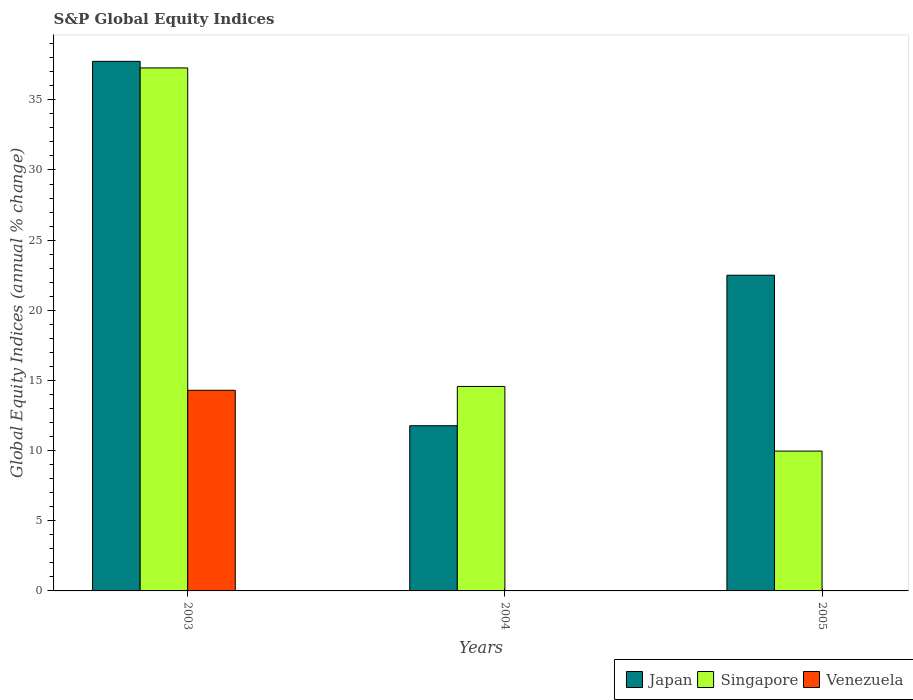How many different coloured bars are there?
Make the answer very short. 3. Are the number of bars per tick equal to the number of legend labels?
Your response must be concise. No. How many bars are there on the 1st tick from the left?
Your answer should be very brief. 3. In how many cases, is the number of bars for a given year not equal to the number of legend labels?
Ensure brevity in your answer.  2. What is the global equity indices in Japan in 2004?
Keep it short and to the point. 11.77. Across all years, what is the maximum global equity indices in Singapore?
Your answer should be very brief. 37.27. Across all years, what is the minimum global equity indices in Japan?
Your response must be concise. 11.77. In which year was the global equity indices in Singapore maximum?
Offer a terse response. 2003. What is the total global equity indices in Singapore in the graph?
Make the answer very short. 61.81. What is the difference between the global equity indices in Japan in 2003 and that in 2005?
Make the answer very short. 15.24. What is the difference between the global equity indices in Japan in 2005 and the global equity indices in Singapore in 2003?
Your response must be concise. -14.77. What is the average global equity indices in Singapore per year?
Your answer should be very brief. 20.6. In the year 2004, what is the difference between the global equity indices in Singapore and global equity indices in Japan?
Your answer should be compact. 2.8. In how many years, is the global equity indices in Japan greater than 6 %?
Keep it short and to the point. 3. What is the ratio of the global equity indices in Singapore in 2004 to that in 2005?
Your response must be concise. 1.46. Is the global equity indices in Singapore in 2003 less than that in 2004?
Your answer should be compact. No. Is the difference between the global equity indices in Singapore in 2003 and 2004 greater than the difference between the global equity indices in Japan in 2003 and 2004?
Make the answer very short. No. What is the difference between the highest and the second highest global equity indices in Japan?
Provide a short and direct response. 15.24. What is the difference between the highest and the lowest global equity indices in Japan?
Give a very brief answer. 25.97. In how many years, is the global equity indices in Venezuela greater than the average global equity indices in Venezuela taken over all years?
Provide a short and direct response. 1. Is it the case that in every year, the sum of the global equity indices in Singapore and global equity indices in Japan is greater than the global equity indices in Venezuela?
Your answer should be compact. Yes. Are the values on the major ticks of Y-axis written in scientific E-notation?
Offer a terse response. No. Does the graph contain any zero values?
Offer a terse response. Yes. Does the graph contain grids?
Offer a very short reply. No. How are the legend labels stacked?
Give a very brief answer. Horizontal. What is the title of the graph?
Offer a terse response. S&P Global Equity Indices. Does "Liechtenstein" appear as one of the legend labels in the graph?
Your response must be concise. No. What is the label or title of the Y-axis?
Give a very brief answer. Global Equity Indices (annual % change). What is the Global Equity Indices (annual % change) of Japan in 2003?
Provide a short and direct response. 37.74. What is the Global Equity Indices (annual % change) in Singapore in 2003?
Give a very brief answer. 37.27. What is the Global Equity Indices (annual % change) of Venezuela in 2003?
Your answer should be compact. 14.3. What is the Global Equity Indices (annual % change) in Japan in 2004?
Keep it short and to the point. 11.77. What is the Global Equity Indices (annual % change) of Singapore in 2004?
Your answer should be very brief. 14.57. What is the Global Equity Indices (annual % change) of Venezuela in 2004?
Offer a terse response. 0. What is the Global Equity Indices (annual % change) in Japan in 2005?
Offer a terse response. 22.5. What is the Global Equity Indices (annual % change) in Singapore in 2005?
Offer a terse response. 9.97. Across all years, what is the maximum Global Equity Indices (annual % change) of Japan?
Keep it short and to the point. 37.74. Across all years, what is the maximum Global Equity Indices (annual % change) of Singapore?
Your answer should be compact. 37.27. Across all years, what is the maximum Global Equity Indices (annual % change) of Venezuela?
Give a very brief answer. 14.3. Across all years, what is the minimum Global Equity Indices (annual % change) of Japan?
Provide a short and direct response. 11.77. Across all years, what is the minimum Global Equity Indices (annual % change) in Singapore?
Offer a terse response. 9.97. What is the total Global Equity Indices (annual % change) in Japan in the graph?
Your answer should be very brief. 72.01. What is the total Global Equity Indices (annual % change) of Singapore in the graph?
Ensure brevity in your answer.  61.81. What is the total Global Equity Indices (annual % change) in Venezuela in the graph?
Provide a succinct answer. 14.3. What is the difference between the Global Equity Indices (annual % change) in Japan in 2003 and that in 2004?
Your answer should be compact. 25.97. What is the difference between the Global Equity Indices (annual % change) of Singapore in 2003 and that in 2004?
Your response must be concise. 22.7. What is the difference between the Global Equity Indices (annual % change) of Japan in 2003 and that in 2005?
Your answer should be compact. 15.24. What is the difference between the Global Equity Indices (annual % change) in Singapore in 2003 and that in 2005?
Offer a terse response. 27.31. What is the difference between the Global Equity Indices (annual % change) in Japan in 2004 and that in 2005?
Provide a succinct answer. -10.73. What is the difference between the Global Equity Indices (annual % change) in Singapore in 2004 and that in 2005?
Give a very brief answer. 4.61. What is the difference between the Global Equity Indices (annual % change) of Japan in 2003 and the Global Equity Indices (annual % change) of Singapore in 2004?
Offer a very short reply. 23.17. What is the difference between the Global Equity Indices (annual % change) in Japan in 2003 and the Global Equity Indices (annual % change) in Singapore in 2005?
Keep it short and to the point. 27.77. What is the difference between the Global Equity Indices (annual % change) in Japan in 2004 and the Global Equity Indices (annual % change) in Singapore in 2005?
Make the answer very short. 1.81. What is the average Global Equity Indices (annual % change) in Japan per year?
Provide a short and direct response. 24. What is the average Global Equity Indices (annual % change) of Singapore per year?
Provide a succinct answer. 20.6. What is the average Global Equity Indices (annual % change) in Venezuela per year?
Your response must be concise. 4.77. In the year 2003, what is the difference between the Global Equity Indices (annual % change) in Japan and Global Equity Indices (annual % change) in Singapore?
Offer a very short reply. 0.47. In the year 2003, what is the difference between the Global Equity Indices (annual % change) in Japan and Global Equity Indices (annual % change) in Venezuela?
Make the answer very short. 23.44. In the year 2003, what is the difference between the Global Equity Indices (annual % change) in Singapore and Global Equity Indices (annual % change) in Venezuela?
Keep it short and to the point. 22.97. In the year 2004, what is the difference between the Global Equity Indices (annual % change) of Japan and Global Equity Indices (annual % change) of Singapore?
Your answer should be very brief. -2.8. In the year 2005, what is the difference between the Global Equity Indices (annual % change) of Japan and Global Equity Indices (annual % change) of Singapore?
Ensure brevity in your answer.  12.53. What is the ratio of the Global Equity Indices (annual % change) of Japan in 2003 to that in 2004?
Ensure brevity in your answer.  3.21. What is the ratio of the Global Equity Indices (annual % change) of Singapore in 2003 to that in 2004?
Offer a very short reply. 2.56. What is the ratio of the Global Equity Indices (annual % change) in Japan in 2003 to that in 2005?
Your response must be concise. 1.68. What is the ratio of the Global Equity Indices (annual % change) in Singapore in 2003 to that in 2005?
Your response must be concise. 3.74. What is the ratio of the Global Equity Indices (annual % change) in Japan in 2004 to that in 2005?
Offer a very short reply. 0.52. What is the ratio of the Global Equity Indices (annual % change) of Singapore in 2004 to that in 2005?
Keep it short and to the point. 1.46. What is the difference between the highest and the second highest Global Equity Indices (annual % change) in Japan?
Keep it short and to the point. 15.24. What is the difference between the highest and the second highest Global Equity Indices (annual % change) of Singapore?
Keep it short and to the point. 22.7. What is the difference between the highest and the lowest Global Equity Indices (annual % change) in Japan?
Your answer should be compact. 25.97. What is the difference between the highest and the lowest Global Equity Indices (annual % change) in Singapore?
Keep it short and to the point. 27.31. What is the difference between the highest and the lowest Global Equity Indices (annual % change) in Venezuela?
Your answer should be very brief. 14.3. 